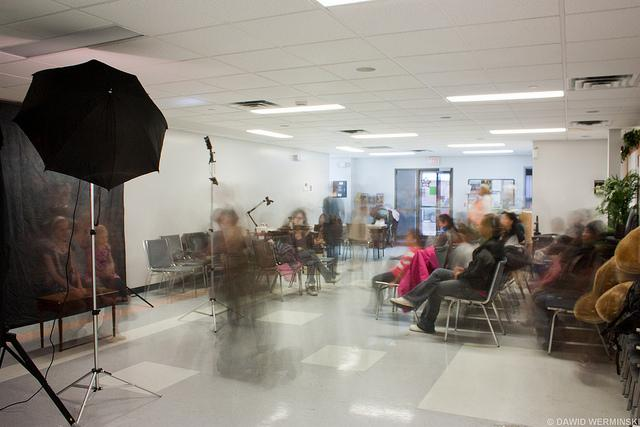What is the umbrella being used for?

Choices:
A) keeping dry
B) decoration
C) lighting
D) to dance lighting 